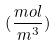<formula> <loc_0><loc_0><loc_500><loc_500>( \frac { m o l } { m ^ { 3 } } )</formula> 